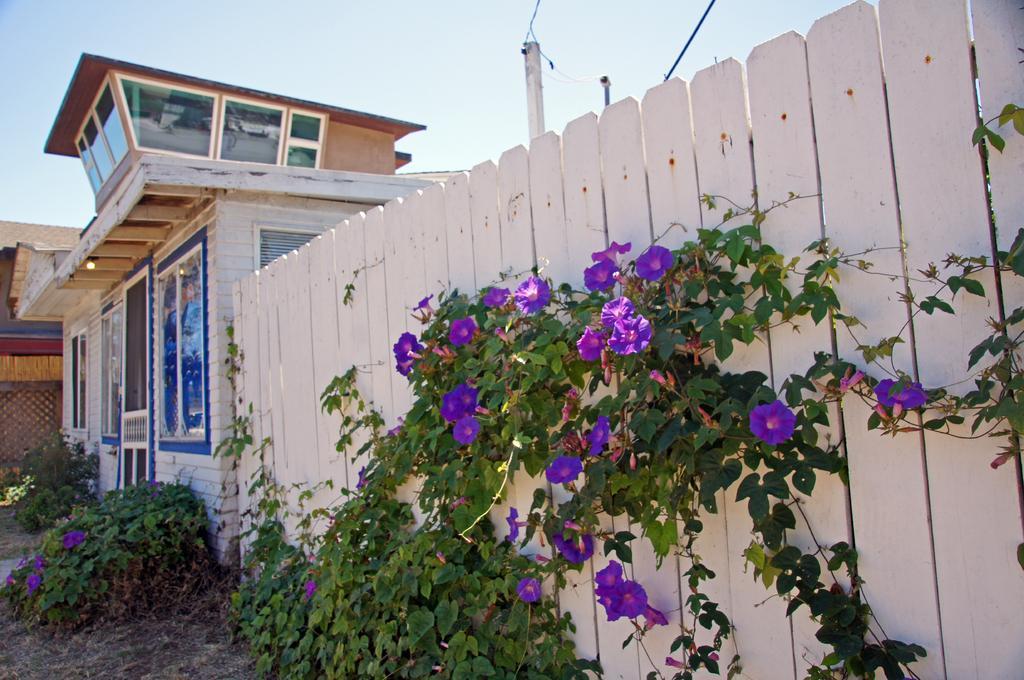Can you describe this image briefly? This image is taken outdoors. At the top of the image there is a sky with clouds. At the bottom of the image there is a ground. On the right side of the image there is a wooden fence. There is a creeper with green leaves and purple colored flowers and there is a pole. On the left side of the image there are two houses and there are a few plants on the ground. 